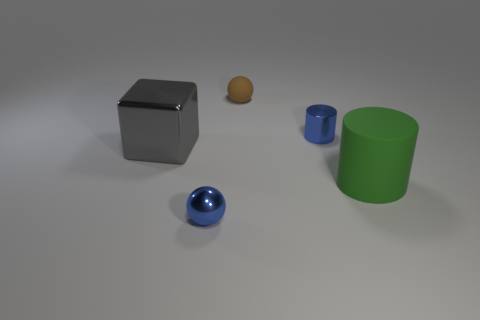What materials do the objects seem to be made from? Based on the image, the objects seem to be made of different materials. The sphere near the front appears to be made of a polished metal, similar to steel or aluminum, due to its reflective surface. The cube is also metallic with a matte finish. The object farthest to the left resembles clay by its matte and slightly rough texture. The two cylindrical objects look to be made of plastic, indicated by their uniform and slightly shiny surfaces. 